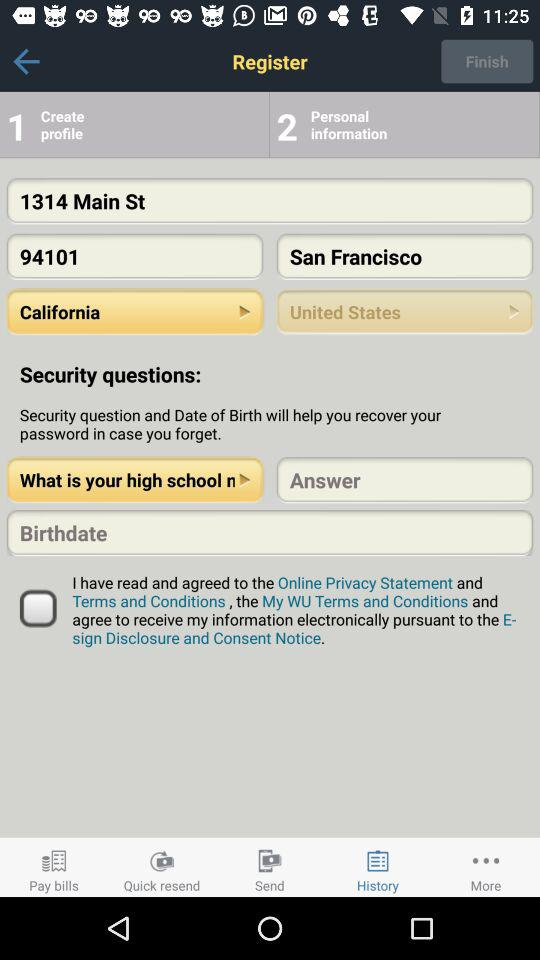What is the location? The location is 1314 Main St, San Francisco, CA 94105, USA. 